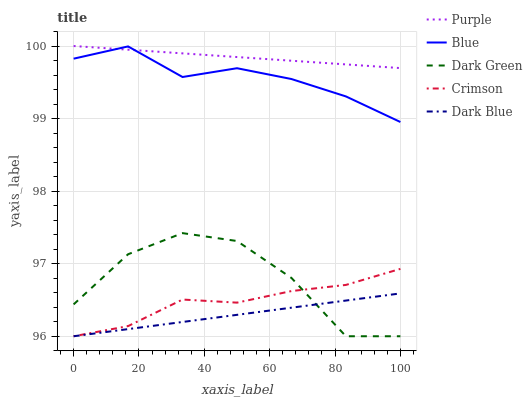Does Dark Blue have the minimum area under the curve?
Answer yes or no. Yes. Does Purple have the maximum area under the curve?
Answer yes or no. Yes. Does Blue have the minimum area under the curve?
Answer yes or no. No. Does Blue have the maximum area under the curve?
Answer yes or no. No. Is Dark Blue the smoothest?
Answer yes or no. Yes. Is Dark Green the roughest?
Answer yes or no. Yes. Is Blue the smoothest?
Answer yes or no. No. Is Blue the roughest?
Answer yes or no. No. Does Dark Blue have the lowest value?
Answer yes or no. Yes. Does Blue have the lowest value?
Answer yes or no. No. Does Purple have the highest value?
Answer yes or no. Yes. Does Blue have the highest value?
Answer yes or no. No. Is Dark Blue less than Purple?
Answer yes or no. Yes. Is Purple greater than Dark Blue?
Answer yes or no. Yes. Does Dark Green intersect Crimson?
Answer yes or no. Yes. Is Dark Green less than Crimson?
Answer yes or no. No. Is Dark Green greater than Crimson?
Answer yes or no. No. Does Dark Blue intersect Purple?
Answer yes or no. No. 